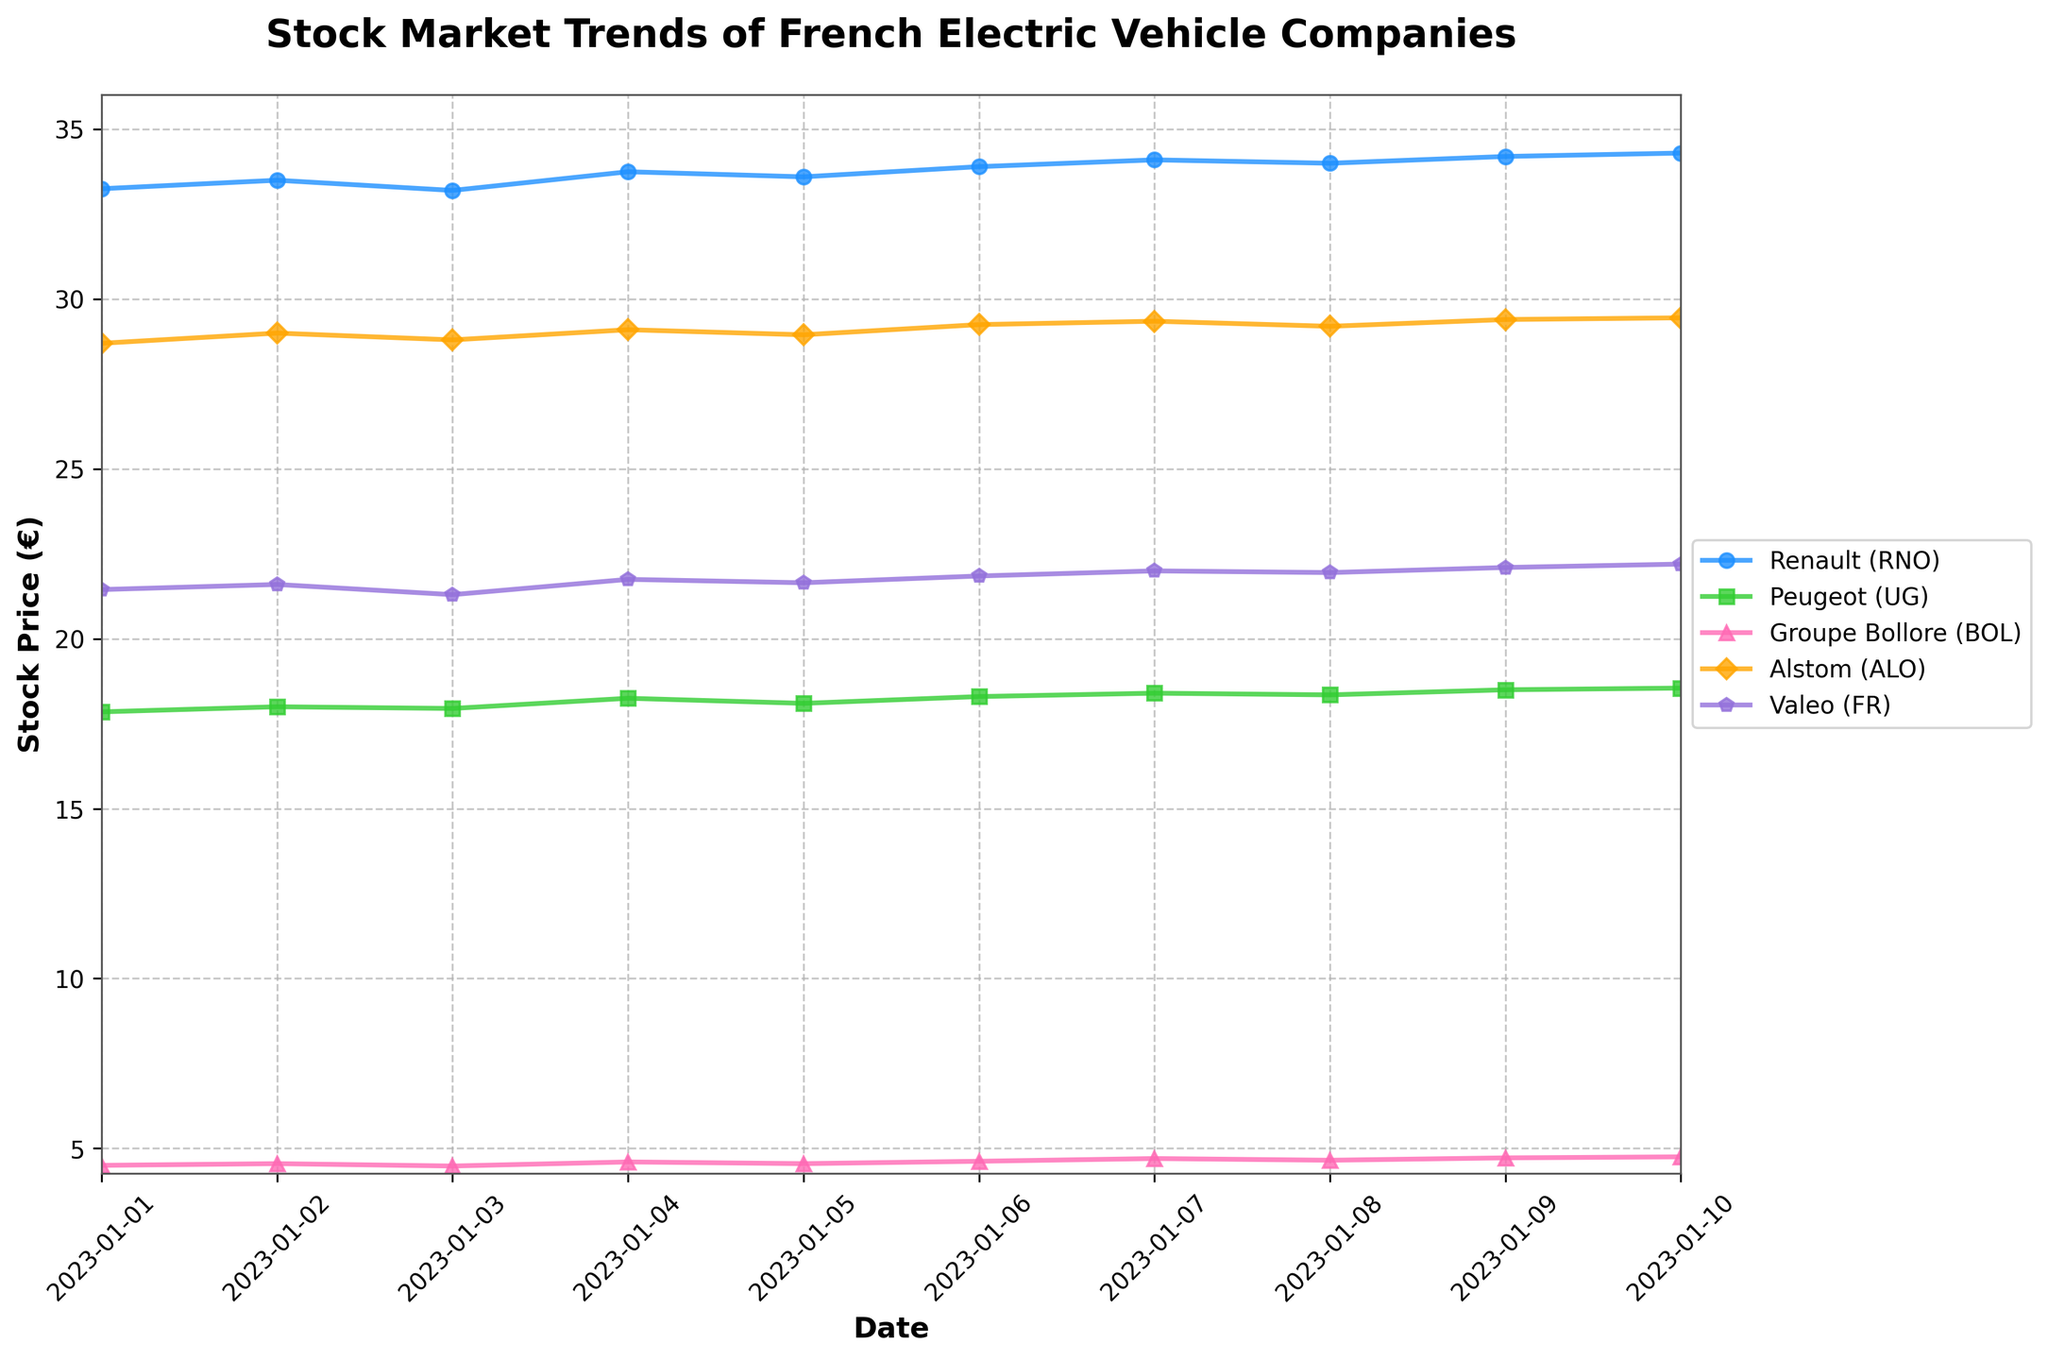When does Renault's stock price first exceed 34.00€? Scan the Renault (RNO) line for the first instance where the price exceeds 34.00€. This occurs on January 07 when the price is 34.10€.
Answer: January 07 Which company shows the most gradual price increase over the dates? By observing the slope of each line, Groupe Bollore (BOL) shows the most gradual increase due to the relatively flat trajectory compared to others.
Answer: Groupe Bollore (BOL) What is the highest stock price for Alstom during the time period? Locate the peak of the line corresponding to Alstom (ALO) which reaches its highest value on January 10 with a price of 29.45€.
Answer: 29.45€ Which company shows the largest fluctuation in stock prices? Compare the vertical range between the highest and lowest points for each company. Renault (RNO) shows the largest fluctuation from 33.20€ to 34.30€ which is a range of 1.10€.
Answer: Renault (RNO) Between January 01 and January 10, how much did Valeo's stock price increase? Subtract the initial value on January 01 (21.45€) from the final value on January 10 (22.20€). This gives an increase of 0.75€.
Answer: 0.75€ On which date did Peugeot's stock price peak? Identify the peak of the Peugeot (UG) line which occurs on January 10 at 18.55€.
Answer: January 10 What is the average stock price of Groupe Bollore over the time period? Sum the daily stock prices of Groupe Bollore (4.50 + 4.55 + 4.48 + 4.60 + 4.55 + 4.62 + 4.70 + 4.65 + 4.72 + 4.75) which equals 45.12, then divide by the number of days (10). The average is 4.512€.
Answer: 4.512€ Which company had the lowest stock price overall and on what date? Identify the lowest points on all lines. Groupe Bollore (BOL) had the lowest price at 4.48€ on January 03.
Answer: Groupe Bollore on January 03 How many times did Alstom's stock price reach above 29.00€? Count the number of times Alstom’s (ALO) stock price exceeds 29.00€: January 02, January 04, January 06, January 07, January 09, and January 10. This occurs 6 times.
Answer: 6 times 